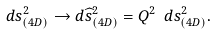Convert formula to latex. <formula><loc_0><loc_0><loc_500><loc_500>d s _ { ( 4 D ) } ^ { 2 } \rightarrow d \widehat { s } _ { ( 4 D ) } ^ { 2 } = Q ^ { 2 } \ d s _ { ( 4 D ) } ^ { 2 } .</formula> 